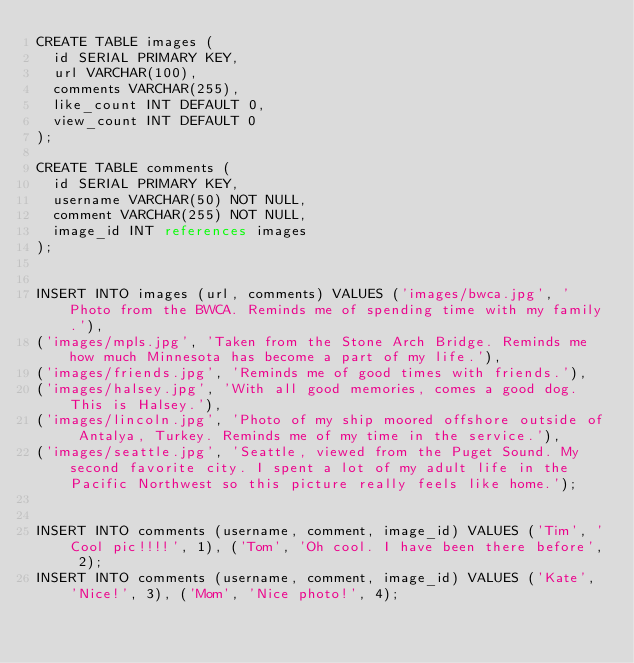<code> <loc_0><loc_0><loc_500><loc_500><_SQL_>CREATE TABLE images (
	id SERIAL PRIMARY KEY,
	url VARCHAR(100),
	comments VARCHAR(255),
	like_count INT DEFAULT 0,
	view_count INT DEFAULT 0
);

CREATE TABLE comments (
	id SERIAL PRIMARY KEY,
	username VARCHAR(50) NOT NULL,
	comment VARCHAR(255) NOT NULL,
	image_id INT references images	
);


INSERT INTO images (url, comments) VALUES ('images/bwca.jpg', 'Photo from the BWCA. Reminds me of spending time with my family.'),
('images/mpls.jpg', 'Taken from the Stone Arch Bridge. Reminds me how much Minnesota has become a part of my life.'),
('images/friends.jpg', 'Reminds me of good times with friends.'),
('images/halsey.jpg', 'With all good memories, comes a good dog. This is Halsey.'),
('images/lincoln.jpg', 'Photo of my ship moored offshore outside of Antalya, Turkey. Reminds me of my time in the service.'),
('images/seattle.jpg', 'Seattle, viewed from the Puget Sound. My second favorite city. I spent a lot of my adult life in the Pacific Northwest so this picture really feels like home.');


INSERT INTO comments (username, comment, image_id) VALUES ('Tim', 'Cool pic!!!!', 1), ('Tom', 'Oh cool. I have been there before', 2);
INSERT INTO comments (username, comment, image_id) VALUES ('Kate', 'Nice!', 3), ('Mom', 'Nice photo!', 4);
</code> 